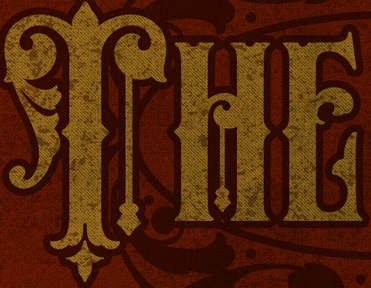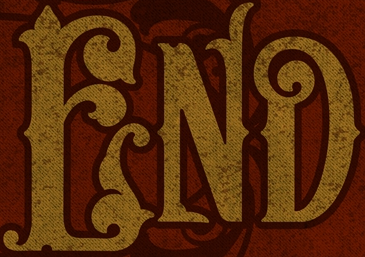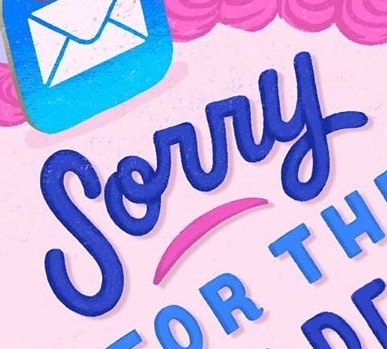What words are shown in these images in order, separated by a semicolon? THE; END; Sorry 